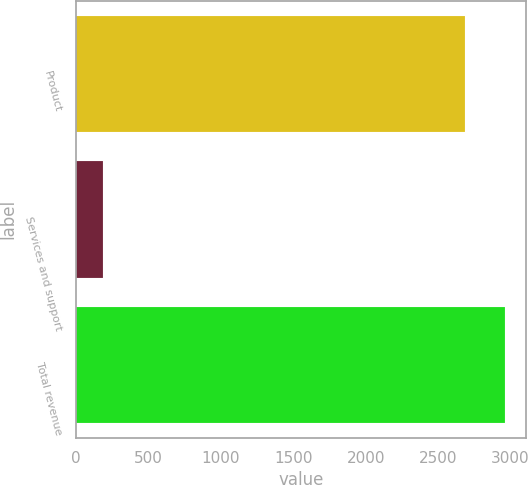Convert chart to OTSL. <chart><loc_0><loc_0><loc_500><loc_500><bar_chart><fcel>Product<fcel>Services and support<fcel>Total revenue<nl><fcel>2684.8<fcel>186.5<fcel>2960.74<nl></chart> 